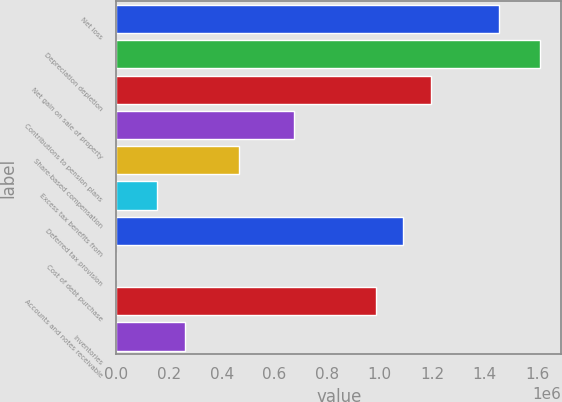Convert chart. <chart><loc_0><loc_0><loc_500><loc_500><bar_chart><fcel>Net loss<fcel>Depreciation depletion<fcel>Net gain on sale of property<fcel>Contributions to pension plans<fcel>Share-based compensation<fcel>Excess tax benefits from<fcel>Deferred tax provision<fcel>Cost of debt purchase<fcel>Accounts and notes receivable<fcel>Inventories<nl><fcel>1.45377e+06<fcel>1.60953e+06<fcel>1.19417e+06<fcel>674965<fcel>467284<fcel>155762<fcel>1.09033e+06<fcel>0.9<fcel>986487<fcel>259602<nl></chart> 